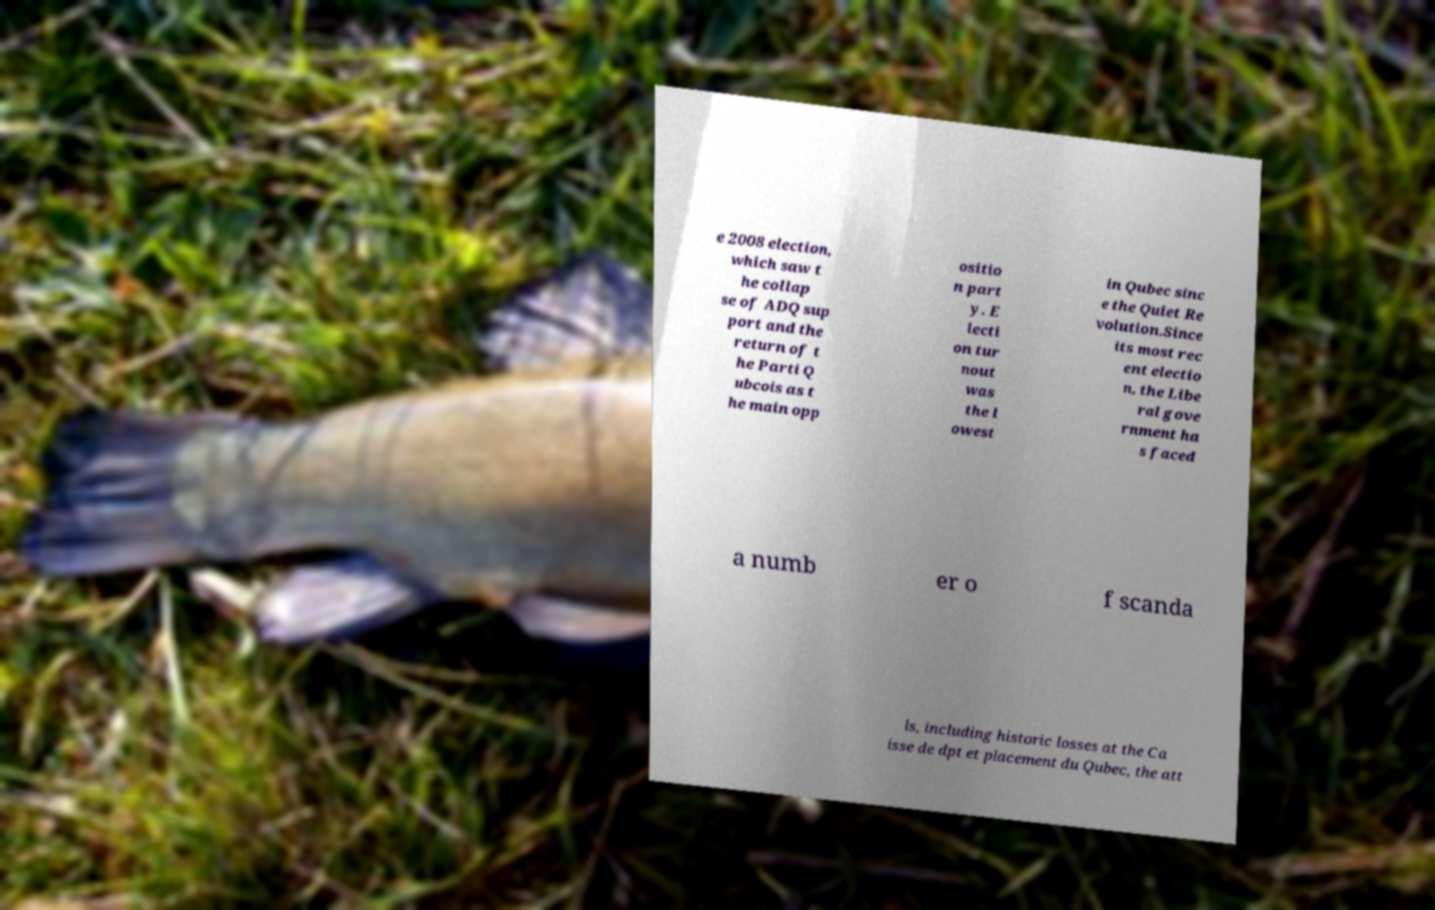There's text embedded in this image that I need extracted. Can you transcribe it verbatim? e 2008 election, which saw t he collap se of ADQ sup port and the return of t he Parti Q ubcois as t he main opp ositio n part y. E lecti on tur nout was the l owest in Qubec sinc e the Quiet Re volution.Since its most rec ent electio n, the Libe ral gove rnment ha s faced a numb er o f scanda ls, including historic losses at the Ca isse de dpt et placement du Qubec, the att 